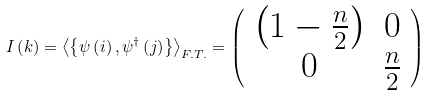Convert formula to latex. <formula><loc_0><loc_0><loc_500><loc_500>I \left ( { k } \right ) = \left \langle \left \{ \psi \left ( i \right ) , \psi ^ { \dagger } \left ( j \right ) \right \} \right \rangle _ { F . T . } = \left ( \begin{array} { c c } \left ( 1 - \frac { n } { 2 } \right ) & { 0 } \\ { 0 } & \frac { n } { 2 } \end{array} \right )</formula> 